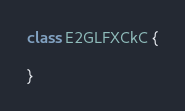Convert code to text. <code><loc_0><loc_0><loc_500><loc_500><_Java_>class E2GLFXCkC {

}
</code> 